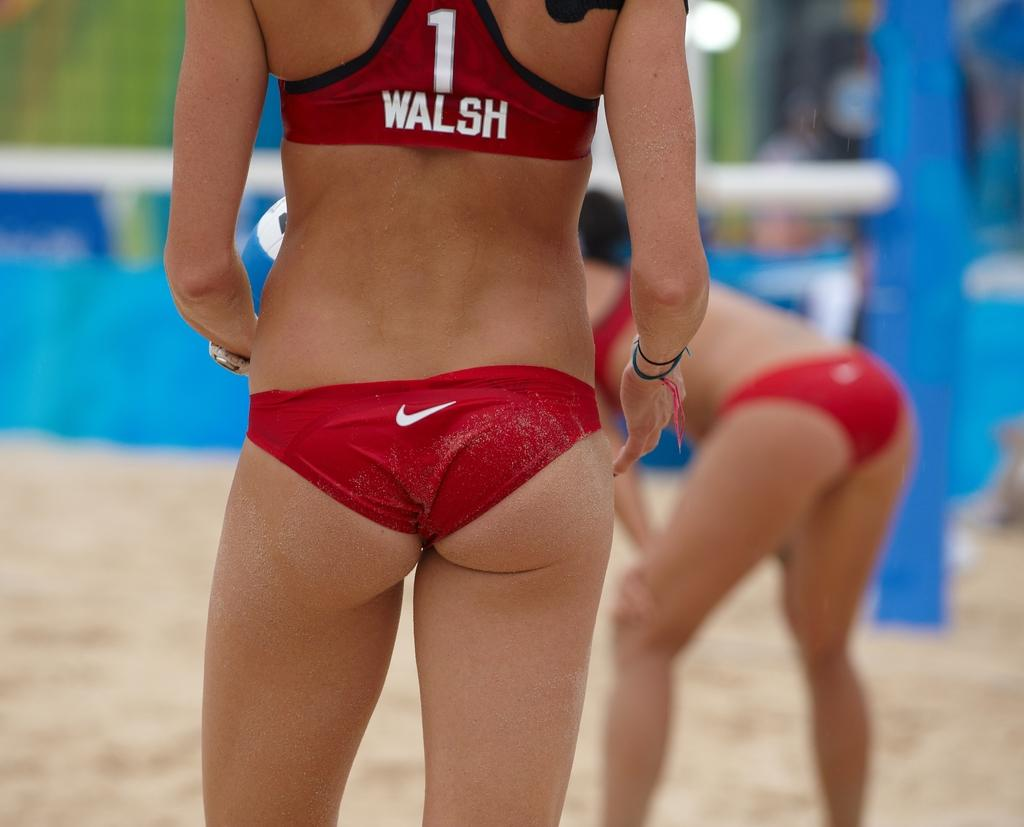<image>
Write a terse but informative summary of the picture. A beach volleyball player has the number 1 and name Walsh on her tiny red strip 